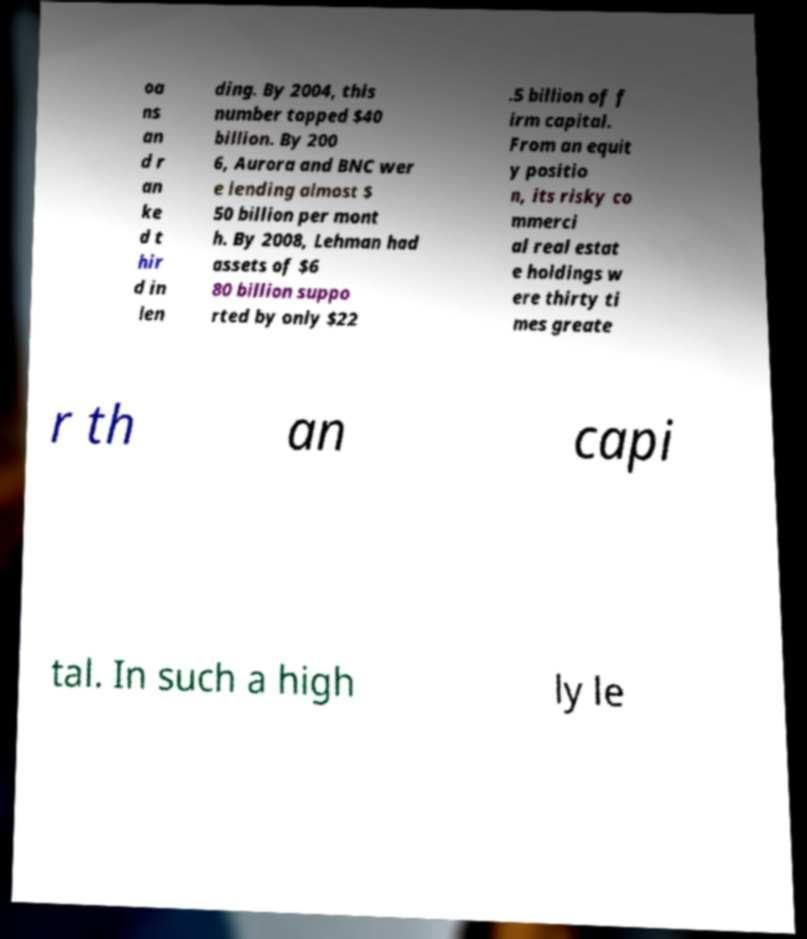Can you read and provide the text displayed in the image?This photo seems to have some interesting text. Can you extract and type it out for me? oa ns an d r an ke d t hir d in len ding. By 2004, this number topped $40 billion. By 200 6, Aurora and BNC wer e lending almost $ 50 billion per mont h. By 2008, Lehman had assets of $6 80 billion suppo rted by only $22 .5 billion of f irm capital. From an equit y positio n, its risky co mmerci al real estat e holdings w ere thirty ti mes greate r th an capi tal. In such a high ly le 